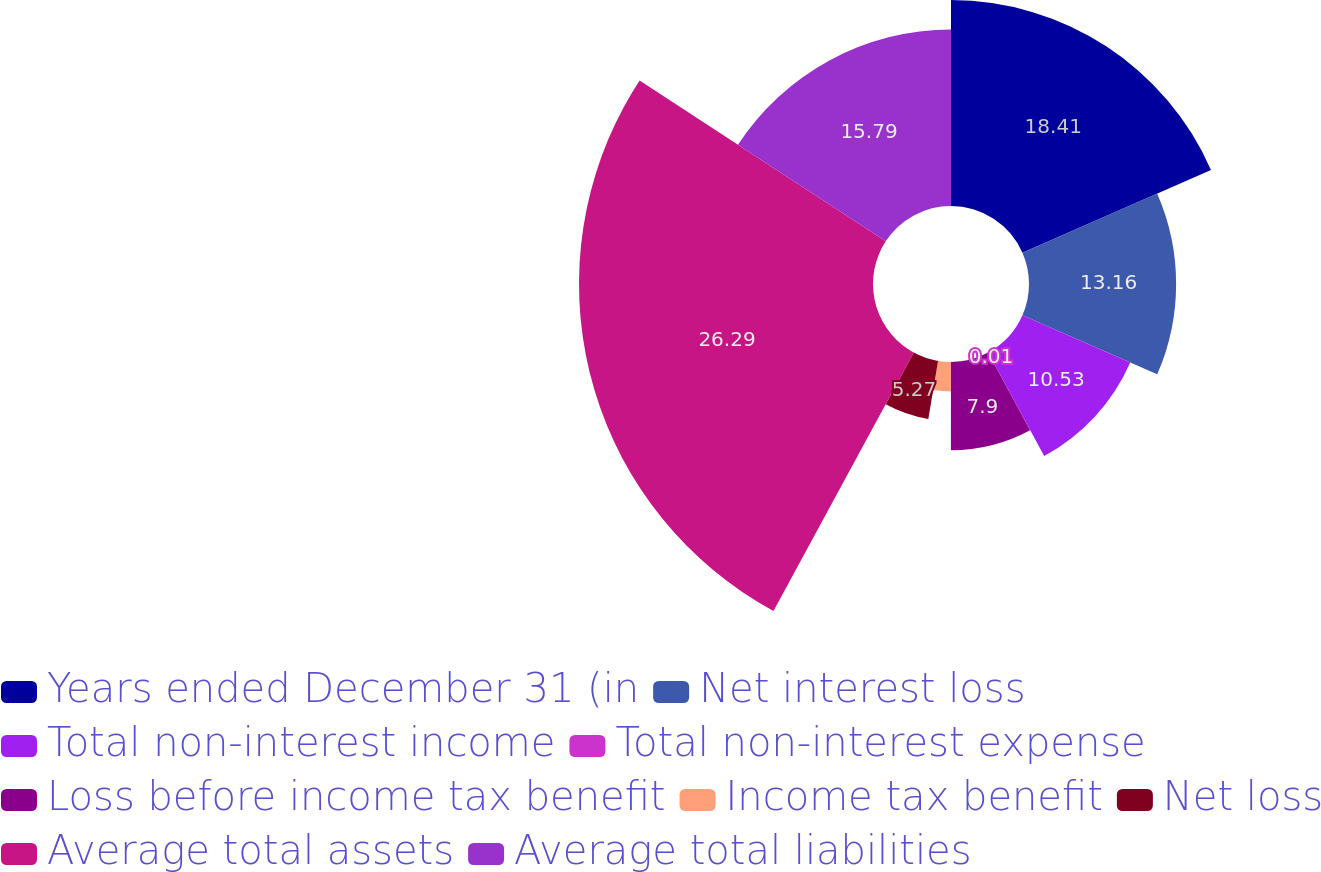<chart> <loc_0><loc_0><loc_500><loc_500><pie_chart><fcel>Years ended December 31 (in<fcel>Net interest loss<fcel>Total non-interest income<fcel>Total non-interest expense<fcel>Loss before income tax benefit<fcel>Income tax benefit<fcel>Net loss<fcel>Average total assets<fcel>Average total liabilities<nl><fcel>18.42%<fcel>13.16%<fcel>10.53%<fcel>0.01%<fcel>7.9%<fcel>2.64%<fcel>5.27%<fcel>26.3%<fcel>15.79%<nl></chart> 